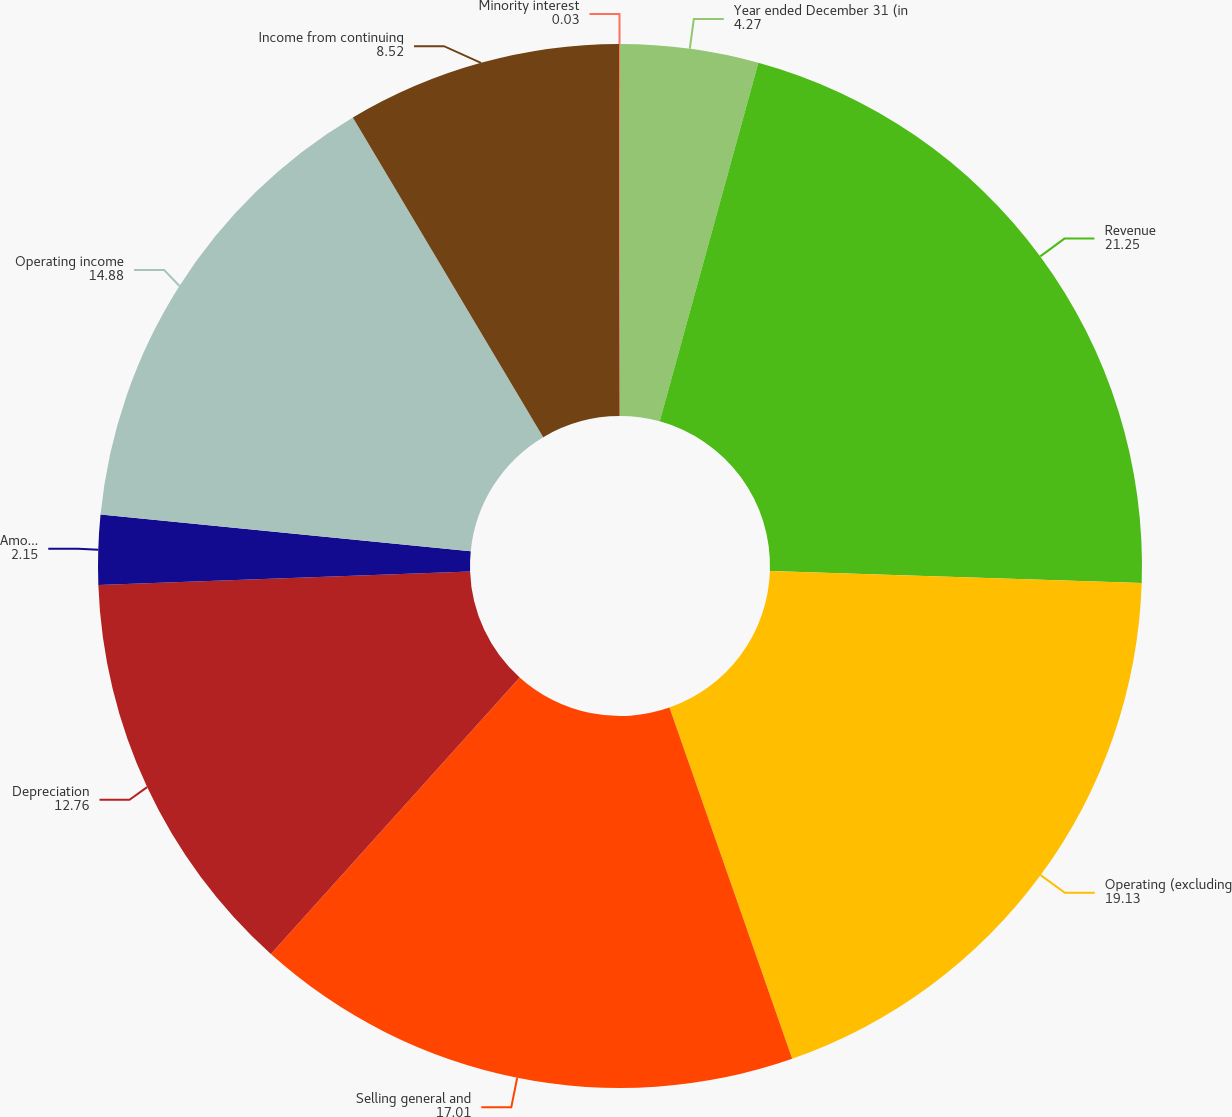Convert chart. <chart><loc_0><loc_0><loc_500><loc_500><pie_chart><fcel>Year ended December 31 (in<fcel>Revenue<fcel>Operating (excluding<fcel>Selling general and<fcel>Depreciation<fcel>Amortization<fcel>Operating income<fcel>Income from continuing<fcel>Minority interest<nl><fcel>4.27%<fcel>21.25%<fcel>19.13%<fcel>17.01%<fcel>12.76%<fcel>2.15%<fcel>14.88%<fcel>8.52%<fcel>0.03%<nl></chart> 